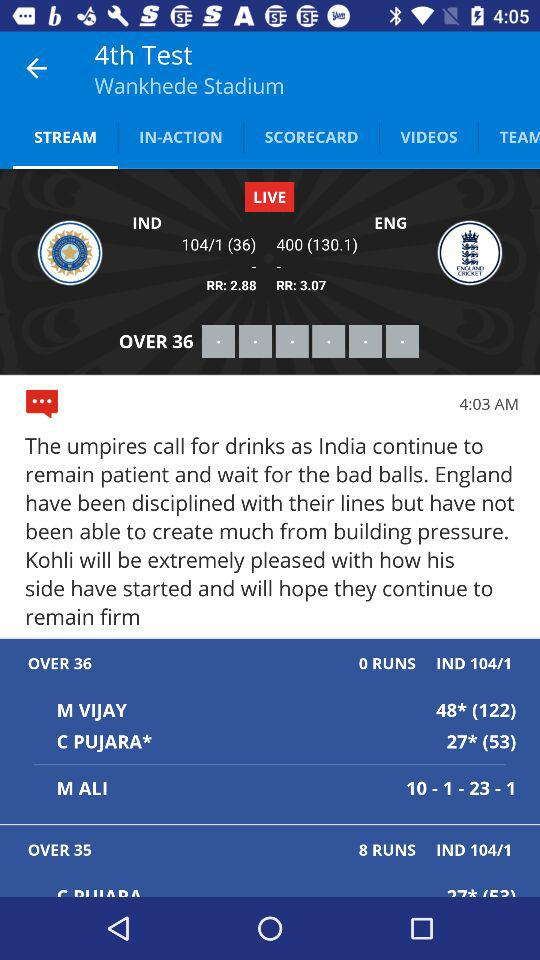What is England's team score? England's team score is 400. 